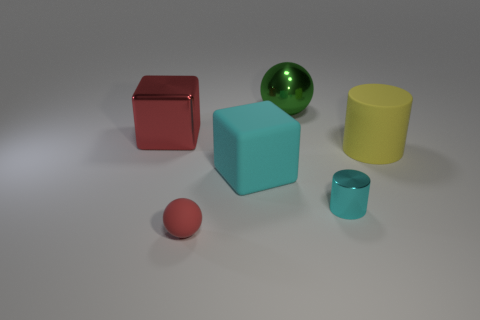Is the number of tiny balls to the left of the cyan shiny cylinder greater than the number of big brown rubber cubes?
Keep it short and to the point. Yes. What is the shape of the large object on the right side of the big thing that is behind the large metallic object in front of the green metal ball?
Your answer should be compact. Cylinder. Does the matte thing that is in front of the tiny cyan cylinder have the same shape as the large object that is left of the big cyan rubber block?
Provide a short and direct response. No. Is there anything else that is the same size as the red sphere?
Offer a very short reply. Yes. Are the green sphere and the small red thing made of the same material?
Provide a short and direct response. No. What number of other objects are the same color as the metal block?
Your response must be concise. 1. There is a object that is to the left of the red matte thing; what shape is it?
Make the answer very short. Cube. Is the size of the matte cube the same as the metal object in front of the red block?
Offer a very short reply. No. What number of other things are there of the same material as the yellow thing
Offer a very short reply. 2. What number of objects are things right of the red metal block or matte things left of the large yellow thing?
Offer a very short reply. 5. 